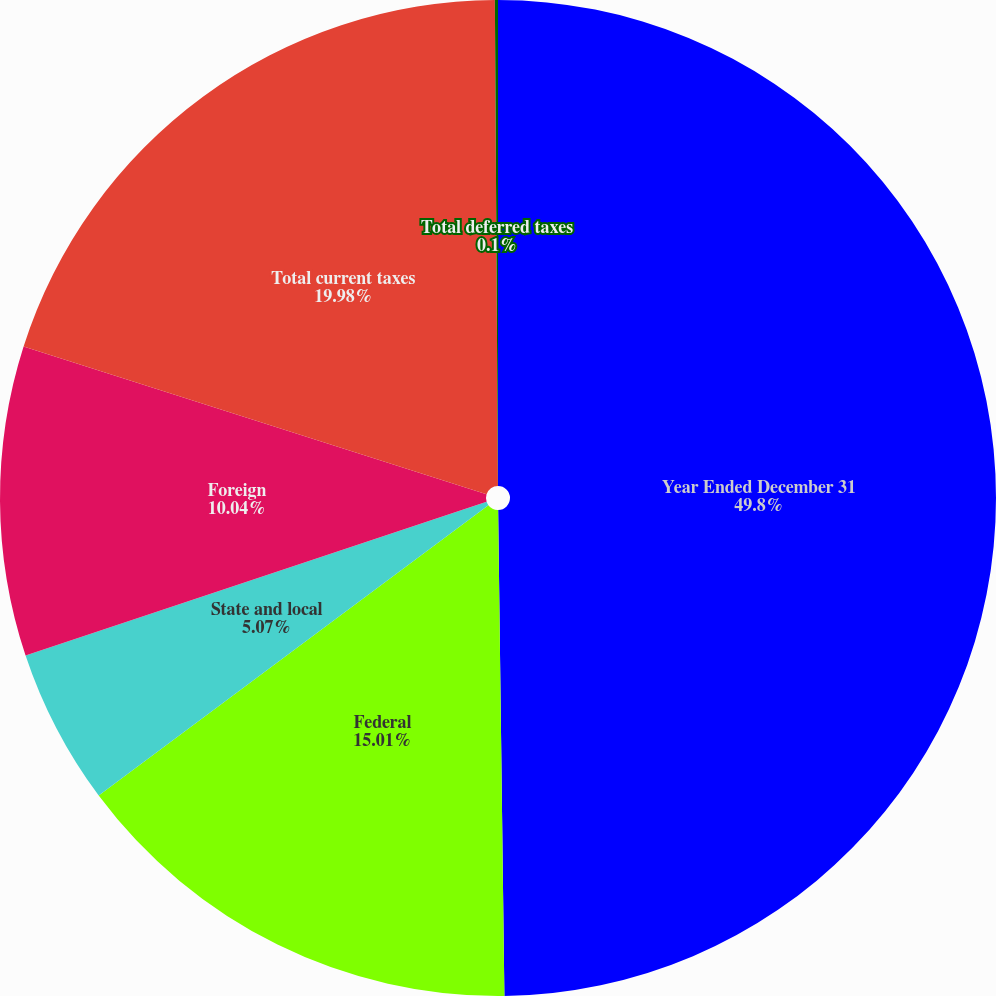Convert chart. <chart><loc_0><loc_0><loc_500><loc_500><pie_chart><fcel>Year Ended December 31<fcel>Federal<fcel>State and local<fcel>Foreign<fcel>Total current taxes<fcel>Total deferred taxes<nl><fcel>49.79%<fcel>15.01%<fcel>5.07%<fcel>10.04%<fcel>19.98%<fcel>0.1%<nl></chart> 